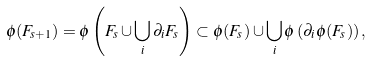<formula> <loc_0><loc_0><loc_500><loc_500>\phi ( F _ { s + 1 } ) = \phi \left ( F _ { s } \cup \bigcup _ { i } \partial _ { i } F _ { s } \right ) \subset \phi ( F _ { s } ) \cup \bigcup _ { i } \phi \left ( \partial _ { i } \phi ( F _ { s } ) \right ) ,</formula> 